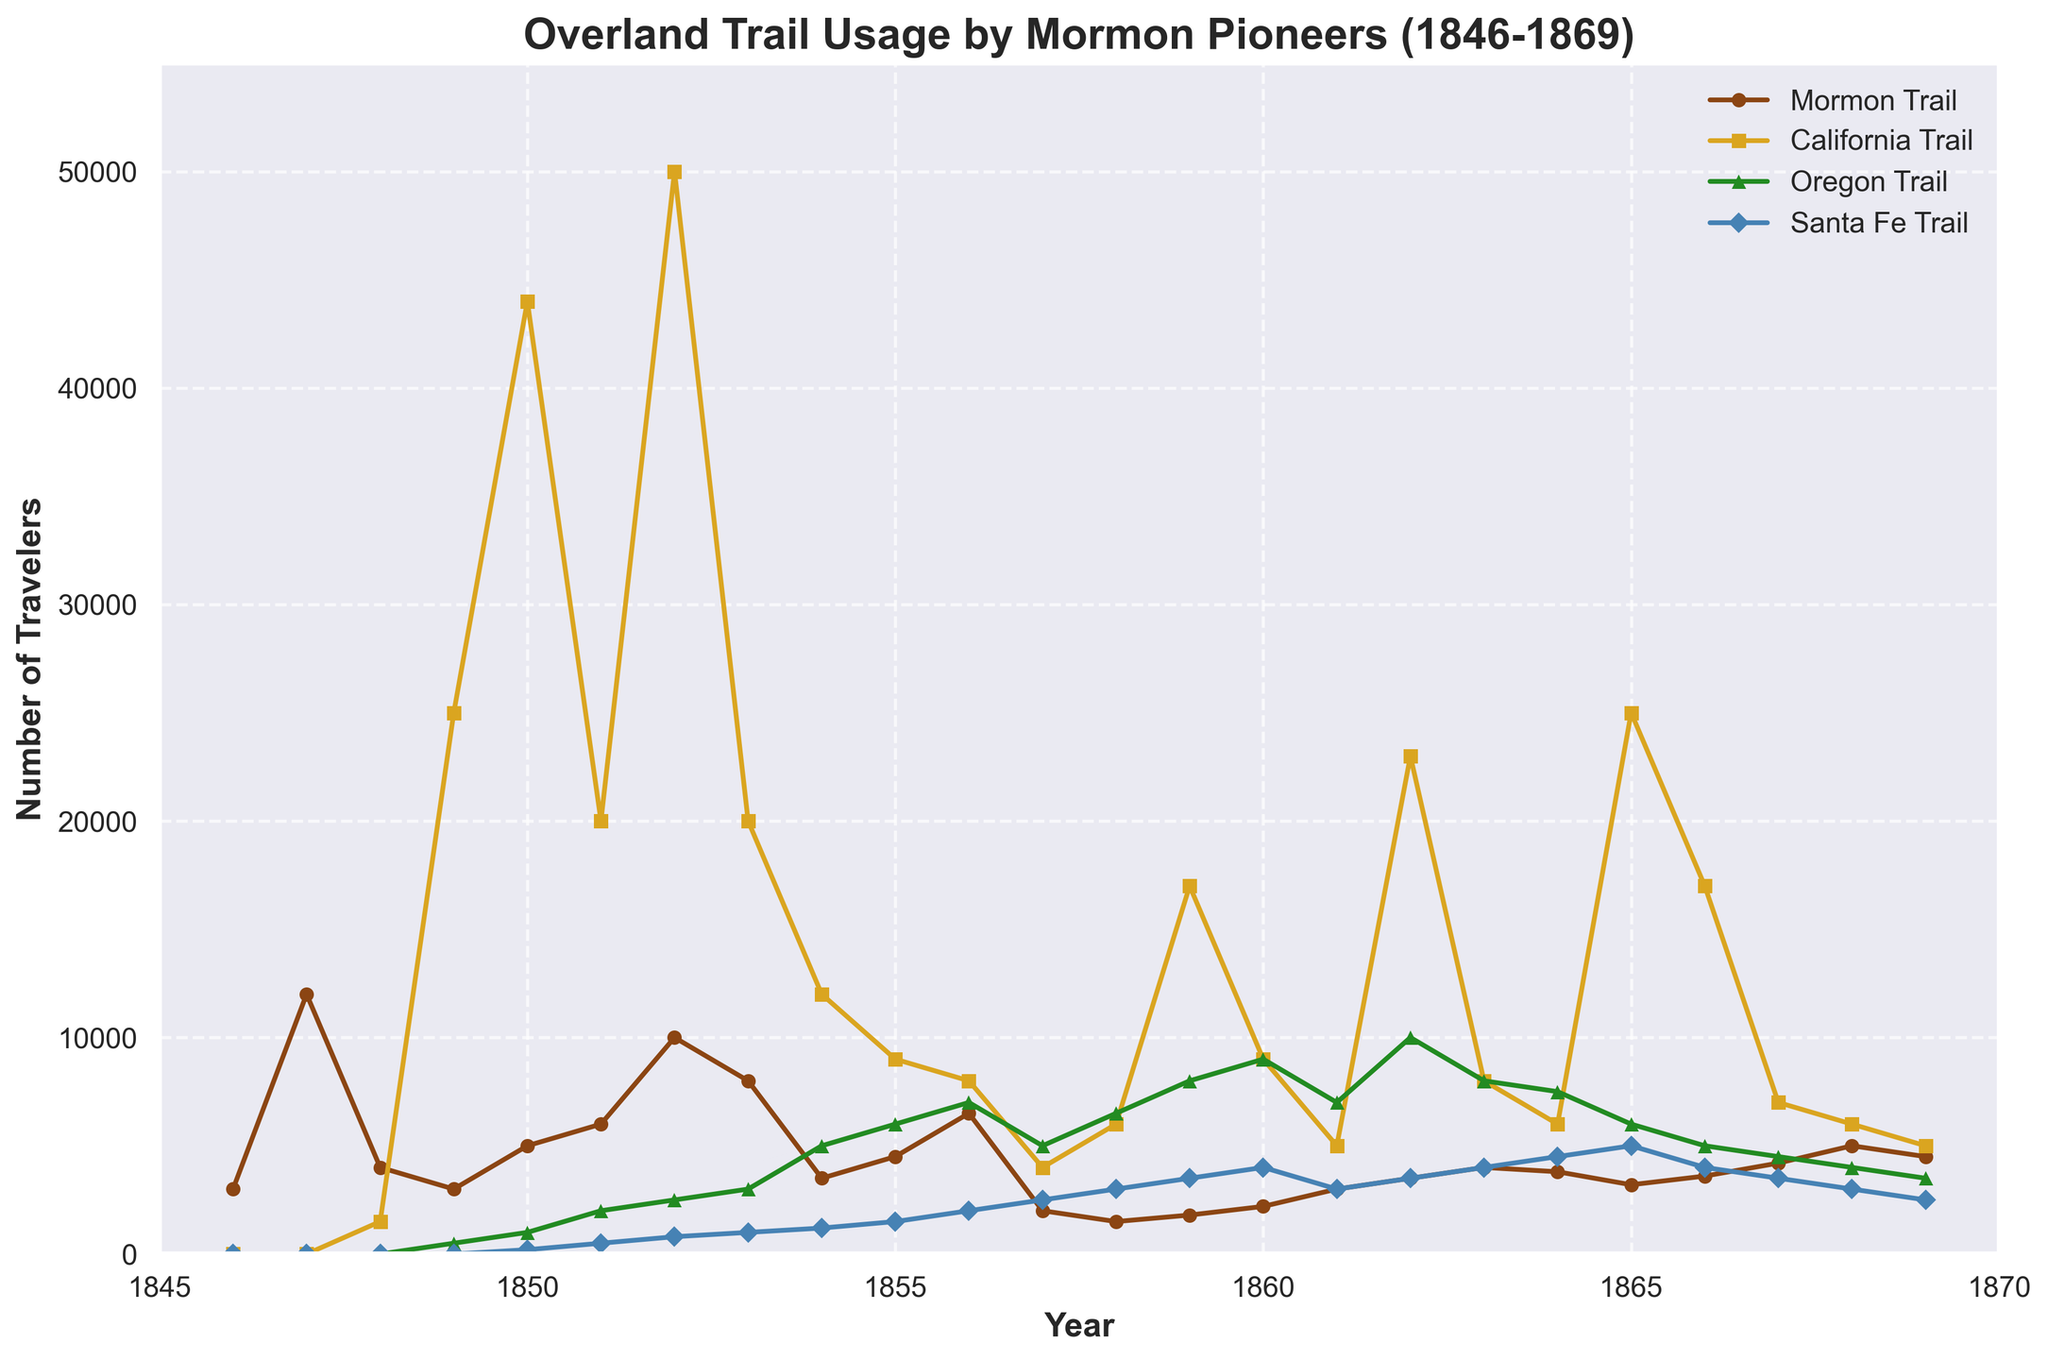What year had the highest usage of the Mormon Trail? Looking at the plot, the number of travelers on the Mormon Trail peaked around 1847. The highest point on the Mormon Trail line is in 1847.
Answer: 1847 In which year did the California Trail see the most travelers, and approximately how many were there? Observing the plot, the California Trail's usage peaked around 1852, where the line reaches its highest point.
Answer: 1852 with approximately 50,000 travelers Compare the number of travelers on the Oregon Trail and the Santa Fe Trail in 1860. Which trail had more travelers and by how much? From the plot, in 1860, the Oregon Trail had 9,000 travelers while the Santa Fe Trail had 4,000 travelers. The Oregon Trail had 5,000 more travelers.
Answer: Oregon Trail by 5,000 What is the trend of the Mormon Trail usage after 1860? Describe the pattern. After 1860, the usage of the Mormon Trail shows a general decreasing trend with some fluctuations. The line generally stays below 5,000 travelers and does not show a significant upsurge.
Answer: Decreasing with fluctuations By what factor did the number of travelers on the California Trail increase from 1848 to 1852? In 1848, the California Trail had 1,500 travelers. By 1852, it had 50,000 travelers. The ratio is 50,000/1,500 which equals approximately 33.33.
Answer: Approximately 33.33 Which trail had the least variability in usage throughout the years 1846 to 1869? Observing the line patterns for all the trails, the Santa Fe Trail's line is the least steep and appears flatter compared to the others, indicating less variability.
Answer: Santa Fe Trail How did the usage of the Oregon Trail compare to the Mormon Trail in 1856? In 1856, the Oregon Trail had 7,000 travelers while the Mormon Trail had 6,500 travelers. The Oregon Trail had more travelers by 500.
Answer: Oregon Trail by 500 What was the combined number of travelers on the Oregon Trail and California Trail in 1863? The plot shows that in 1863, the Oregon Trail had 8,000 travelers, and the California Trail had 8,000 travelers. Summing these yields 8,000 + 8,000 = 16,000 travelers.
Answer: 16,000 